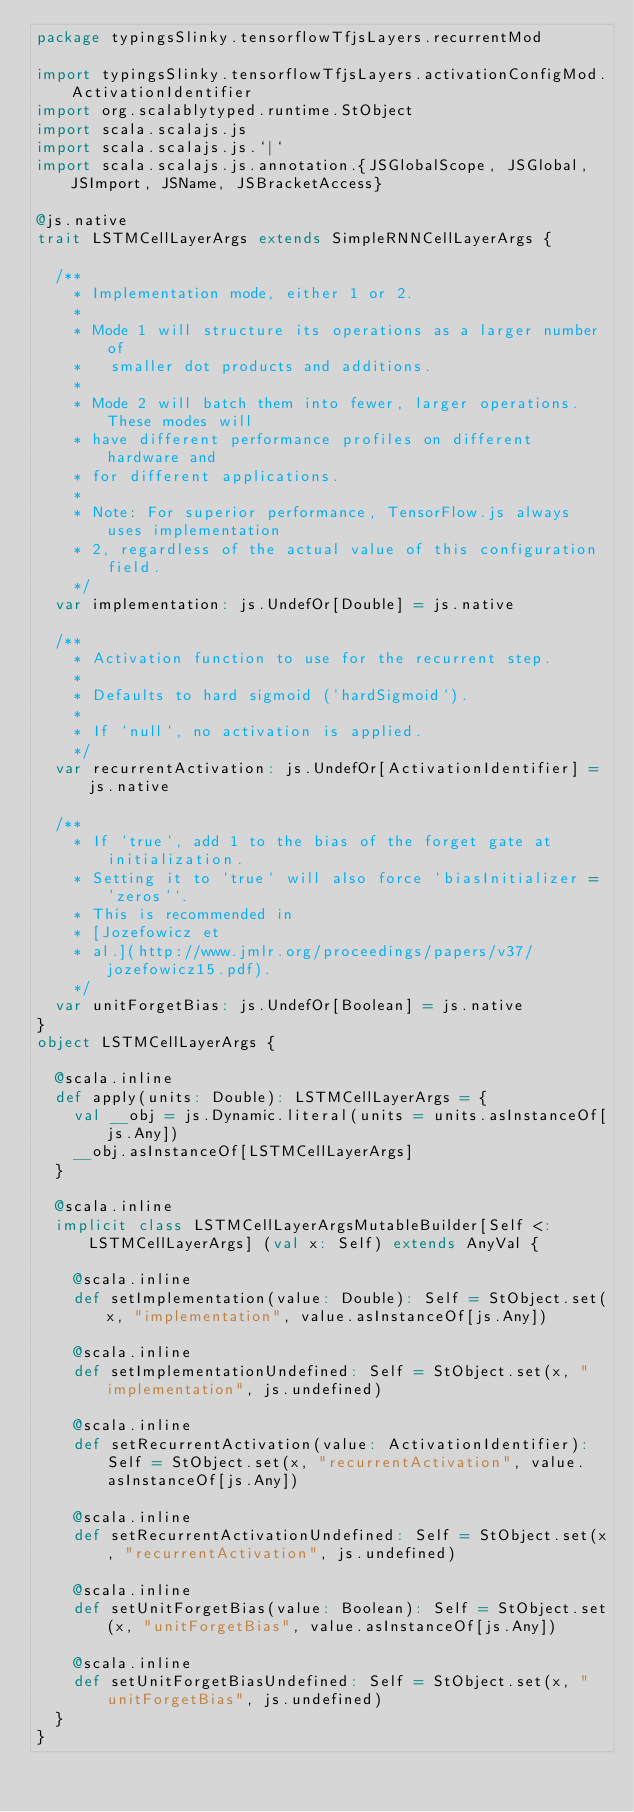<code> <loc_0><loc_0><loc_500><loc_500><_Scala_>package typingsSlinky.tensorflowTfjsLayers.recurrentMod

import typingsSlinky.tensorflowTfjsLayers.activationConfigMod.ActivationIdentifier
import org.scalablytyped.runtime.StObject
import scala.scalajs.js
import scala.scalajs.js.`|`
import scala.scalajs.js.annotation.{JSGlobalScope, JSGlobal, JSImport, JSName, JSBracketAccess}

@js.native
trait LSTMCellLayerArgs extends SimpleRNNCellLayerArgs {
  
  /**
    * Implementation mode, either 1 or 2.
    *
    * Mode 1 will structure its operations as a larger number of
    *   smaller dot products and additions.
    *
    * Mode 2 will batch them into fewer, larger operations. These modes will
    * have different performance profiles on different hardware and
    * for different applications.
    *
    * Note: For superior performance, TensorFlow.js always uses implementation
    * 2, regardless of the actual value of this configuration field.
    */
  var implementation: js.UndefOr[Double] = js.native
  
  /**
    * Activation function to use for the recurrent step.
    *
    * Defaults to hard sigmoid (`hardSigmoid`).
    *
    * If `null`, no activation is applied.
    */
  var recurrentActivation: js.UndefOr[ActivationIdentifier] = js.native
  
  /**
    * If `true`, add 1 to the bias of the forget gate at initialization.
    * Setting it to `true` will also force `biasInitializer = 'zeros'`.
    * This is recommended in
    * [Jozefowicz et
    * al.](http://www.jmlr.org/proceedings/papers/v37/jozefowicz15.pdf).
    */
  var unitForgetBias: js.UndefOr[Boolean] = js.native
}
object LSTMCellLayerArgs {
  
  @scala.inline
  def apply(units: Double): LSTMCellLayerArgs = {
    val __obj = js.Dynamic.literal(units = units.asInstanceOf[js.Any])
    __obj.asInstanceOf[LSTMCellLayerArgs]
  }
  
  @scala.inline
  implicit class LSTMCellLayerArgsMutableBuilder[Self <: LSTMCellLayerArgs] (val x: Self) extends AnyVal {
    
    @scala.inline
    def setImplementation(value: Double): Self = StObject.set(x, "implementation", value.asInstanceOf[js.Any])
    
    @scala.inline
    def setImplementationUndefined: Self = StObject.set(x, "implementation", js.undefined)
    
    @scala.inline
    def setRecurrentActivation(value: ActivationIdentifier): Self = StObject.set(x, "recurrentActivation", value.asInstanceOf[js.Any])
    
    @scala.inline
    def setRecurrentActivationUndefined: Self = StObject.set(x, "recurrentActivation", js.undefined)
    
    @scala.inline
    def setUnitForgetBias(value: Boolean): Self = StObject.set(x, "unitForgetBias", value.asInstanceOf[js.Any])
    
    @scala.inline
    def setUnitForgetBiasUndefined: Self = StObject.set(x, "unitForgetBias", js.undefined)
  }
}
</code> 